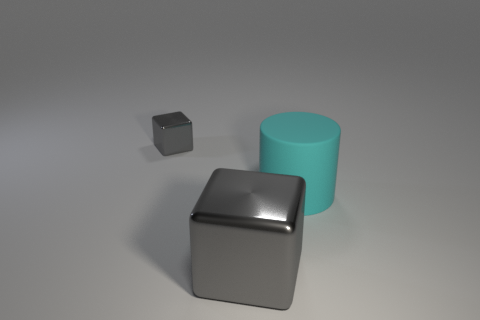Add 3 large shiny cubes. How many objects exist? 6 Add 2 small objects. How many small objects are left? 3 Add 1 metallic blocks. How many metallic blocks exist? 3 Subtract 0 red cylinders. How many objects are left? 3 Subtract all cylinders. How many objects are left? 2 Subtract all gray things. Subtract all blue things. How many objects are left? 1 